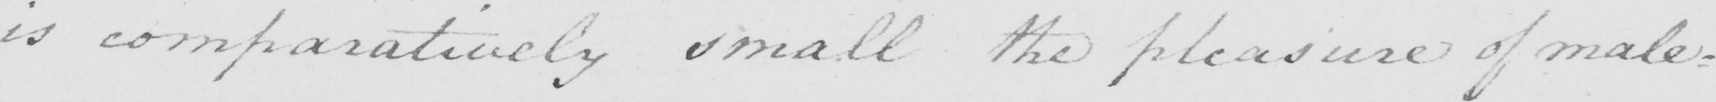What is written in this line of handwriting? is comparatively small the pleasure of male= 